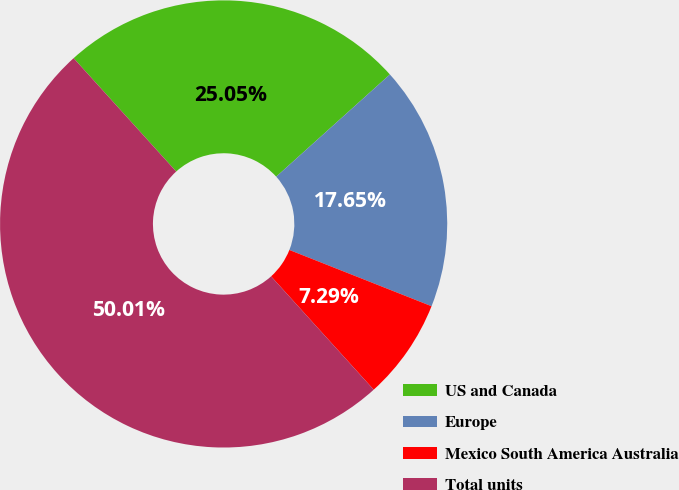Convert chart. <chart><loc_0><loc_0><loc_500><loc_500><pie_chart><fcel>US and Canada<fcel>Europe<fcel>Mexico South America Australia<fcel>Total units<nl><fcel>25.05%<fcel>17.65%<fcel>7.29%<fcel>50.0%<nl></chart> 